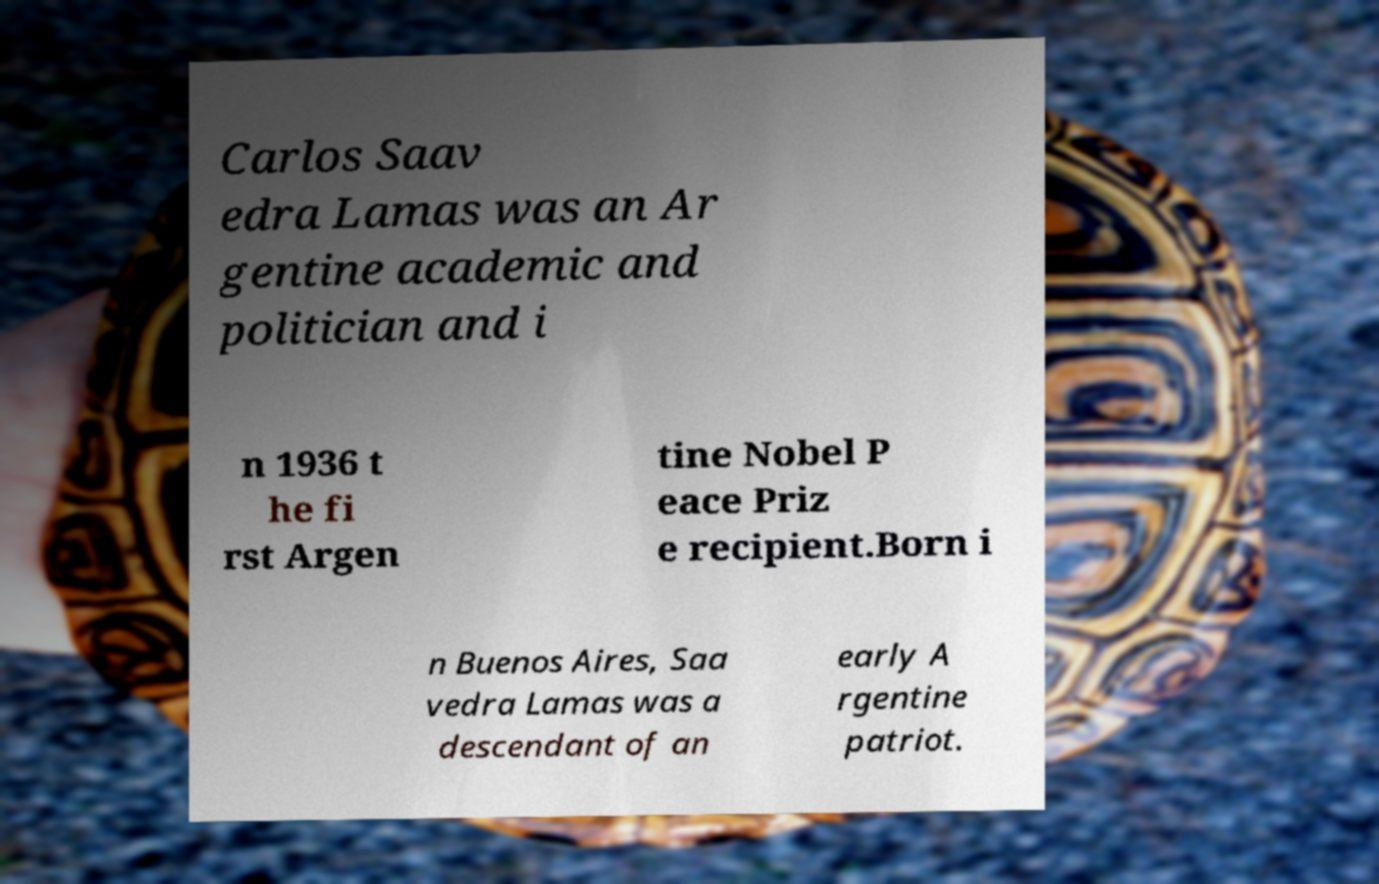Can you read and provide the text displayed in the image?This photo seems to have some interesting text. Can you extract and type it out for me? Carlos Saav edra Lamas was an Ar gentine academic and politician and i n 1936 t he fi rst Argen tine Nobel P eace Priz e recipient.Born i n Buenos Aires, Saa vedra Lamas was a descendant of an early A rgentine patriot. 